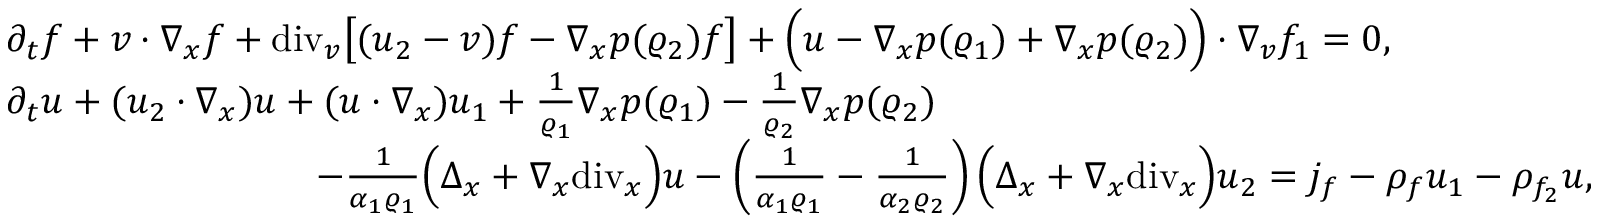<formula> <loc_0><loc_0><loc_500><loc_500>\begin{array} { r l } & { \partial _ { t } f + v \cdot \nabla _ { x } f + d i v _ { v } \left [ ( u _ { 2 } - v ) f - \nabla _ { x } p ( \varrho _ { 2 } ) f \right ] + \left ( u - \nabla _ { x } p ( \varrho _ { 1 } ) + \nabla _ { x } p ( \varrho _ { 2 } ) \right ) \cdot \nabla _ { v } f _ { 1 } = 0 , } \\ & { \partial _ { t } u + ( u _ { 2 } \cdot \nabla _ { x } ) u + ( u \cdot \nabla _ { x } ) u _ { 1 } + \frac { 1 } { \varrho _ { 1 } } \nabla _ { x } p ( \varrho _ { 1 } ) - \frac { 1 } { \varrho _ { 2 } } \nabla _ { x } p ( \varrho _ { 2 } ) } \\ & { \quad - \frac { 1 } { \alpha _ { 1 } \varrho _ { 1 } } \left ( \Delta _ { x } + \nabla _ { x } d i v _ { x } \right ) u - \left ( \frac { 1 } { \alpha _ { 1 } \varrho _ { 1 } } - \frac { 1 } { \alpha _ { 2 } \varrho _ { 2 } } \right ) \left ( \Delta _ { x } + \nabla _ { x } d i v _ { x } \right ) u _ { 2 } = j _ { f } - \rho _ { f } u _ { 1 } - \rho _ { f _ { 2 } } u , } \end{array}</formula> 